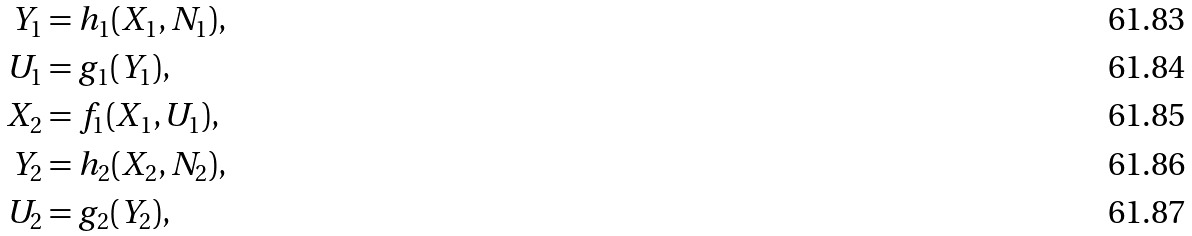Convert formula to latex. <formula><loc_0><loc_0><loc_500><loc_500>Y _ { 1 } & = h _ { 1 } ( X _ { 1 } , N _ { 1 } ) , \\ U _ { 1 } & = g _ { 1 } ( Y _ { 1 } ) , \\ X _ { 2 } & = f _ { 1 } ( X _ { 1 } , U _ { 1 } ) , \\ Y _ { 2 } & = h _ { 2 } ( X _ { 2 } , N _ { 2 } ) , \\ U _ { 2 } & = g _ { 2 } ( Y _ { 2 } ) ,</formula> 